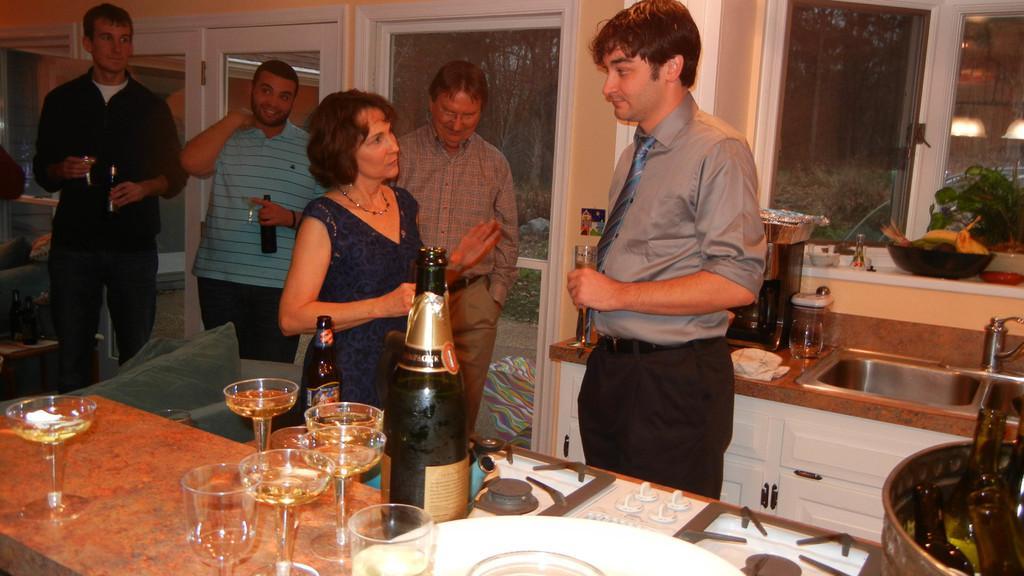Could you give a brief overview of what you see in this image? This picture shows a group of people standing and we see two men holding a bottles in their hand and we see a man holding wine glass and his hand and BC few wine glasses and bottles on the countertop can we see a gas stove wash basin 